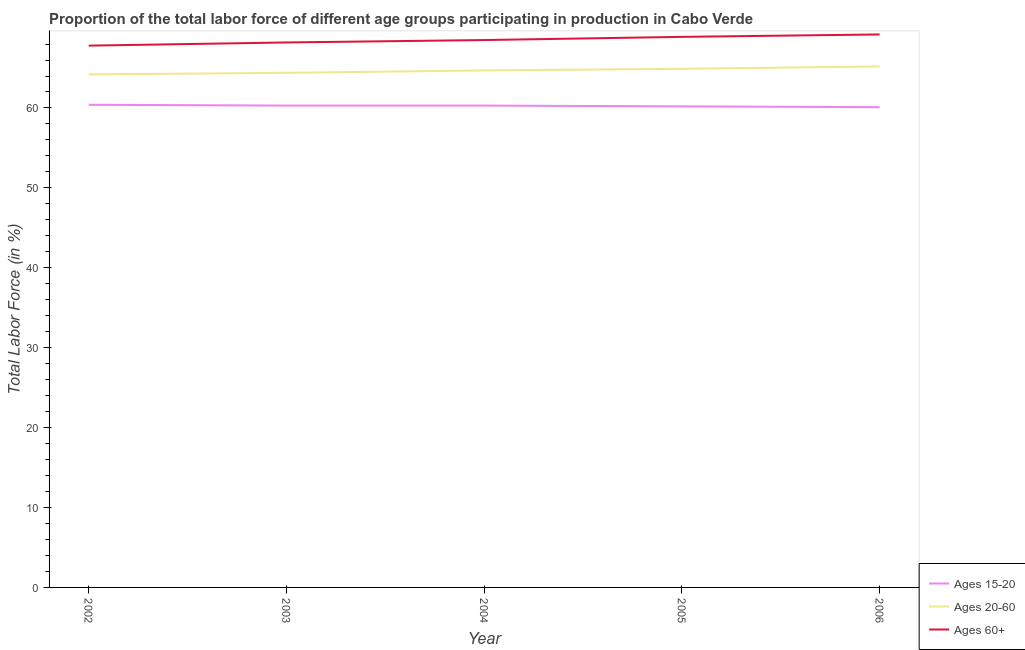What is the percentage of labor force within the age group 15-20 in 2002?
Give a very brief answer. 60.4. Across all years, what is the maximum percentage of labor force above age 60?
Provide a succinct answer. 69.2. Across all years, what is the minimum percentage of labor force within the age group 20-60?
Ensure brevity in your answer.  64.2. In which year was the percentage of labor force above age 60 maximum?
Your answer should be very brief. 2006. In which year was the percentage of labor force within the age group 20-60 minimum?
Ensure brevity in your answer.  2002. What is the total percentage of labor force within the age group 15-20 in the graph?
Your answer should be very brief. 301.3. What is the difference between the percentage of labor force above age 60 in 2005 and that in 2006?
Offer a very short reply. -0.3. What is the difference between the percentage of labor force above age 60 in 2006 and the percentage of labor force within the age group 20-60 in 2003?
Provide a succinct answer. 4.8. What is the average percentage of labor force within the age group 20-60 per year?
Provide a short and direct response. 64.68. In the year 2005, what is the difference between the percentage of labor force within the age group 20-60 and percentage of labor force above age 60?
Your response must be concise. -4. What is the ratio of the percentage of labor force within the age group 15-20 in 2004 to that in 2005?
Your answer should be very brief. 1. What is the difference between the highest and the second highest percentage of labor force above age 60?
Your response must be concise. 0.3. Is the sum of the percentage of labor force within the age group 15-20 in 2003 and 2004 greater than the maximum percentage of labor force above age 60 across all years?
Your answer should be compact. Yes. Is the percentage of labor force within the age group 15-20 strictly greater than the percentage of labor force within the age group 20-60 over the years?
Ensure brevity in your answer.  No. How many lines are there?
Provide a short and direct response. 3. How many years are there in the graph?
Ensure brevity in your answer.  5. What is the difference between two consecutive major ticks on the Y-axis?
Give a very brief answer. 10. Are the values on the major ticks of Y-axis written in scientific E-notation?
Provide a short and direct response. No. How many legend labels are there?
Keep it short and to the point. 3. What is the title of the graph?
Offer a terse response. Proportion of the total labor force of different age groups participating in production in Cabo Verde. What is the label or title of the Y-axis?
Offer a very short reply. Total Labor Force (in %). What is the Total Labor Force (in %) in Ages 15-20 in 2002?
Your answer should be very brief. 60.4. What is the Total Labor Force (in %) in Ages 20-60 in 2002?
Your answer should be very brief. 64.2. What is the Total Labor Force (in %) of Ages 60+ in 2002?
Provide a succinct answer. 67.8. What is the Total Labor Force (in %) of Ages 15-20 in 2003?
Your answer should be very brief. 60.3. What is the Total Labor Force (in %) of Ages 20-60 in 2003?
Offer a very short reply. 64.4. What is the Total Labor Force (in %) of Ages 60+ in 2003?
Offer a very short reply. 68.2. What is the Total Labor Force (in %) of Ages 15-20 in 2004?
Offer a terse response. 60.3. What is the Total Labor Force (in %) of Ages 20-60 in 2004?
Your answer should be compact. 64.7. What is the Total Labor Force (in %) in Ages 60+ in 2004?
Provide a succinct answer. 68.5. What is the Total Labor Force (in %) in Ages 15-20 in 2005?
Make the answer very short. 60.2. What is the Total Labor Force (in %) in Ages 20-60 in 2005?
Keep it short and to the point. 64.9. What is the Total Labor Force (in %) in Ages 60+ in 2005?
Offer a terse response. 68.9. What is the Total Labor Force (in %) of Ages 15-20 in 2006?
Provide a short and direct response. 60.1. What is the Total Labor Force (in %) of Ages 20-60 in 2006?
Offer a very short reply. 65.2. What is the Total Labor Force (in %) of Ages 60+ in 2006?
Offer a very short reply. 69.2. Across all years, what is the maximum Total Labor Force (in %) in Ages 15-20?
Your answer should be very brief. 60.4. Across all years, what is the maximum Total Labor Force (in %) in Ages 20-60?
Provide a succinct answer. 65.2. Across all years, what is the maximum Total Labor Force (in %) of Ages 60+?
Give a very brief answer. 69.2. Across all years, what is the minimum Total Labor Force (in %) in Ages 15-20?
Offer a very short reply. 60.1. Across all years, what is the minimum Total Labor Force (in %) of Ages 20-60?
Provide a short and direct response. 64.2. Across all years, what is the minimum Total Labor Force (in %) of Ages 60+?
Provide a succinct answer. 67.8. What is the total Total Labor Force (in %) in Ages 15-20 in the graph?
Provide a short and direct response. 301.3. What is the total Total Labor Force (in %) in Ages 20-60 in the graph?
Provide a short and direct response. 323.4. What is the total Total Labor Force (in %) of Ages 60+ in the graph?
Your answer should be compact. 342.6. What is the difference between the Total Labor Force (in %) of Ages 15-20 in 2002 and that in 2003?
Your answer should be very brief. 0.1. What is the difference between the Total Labor Force (in %) in Ages 15-20 in 2002 and that in 2004?
Offer a terse response. 0.1. What is the difference between the Total Labor Force (in %) of Ages 20-60 in 2002 and that in 2004?
Keep it short and to the point. -0.5. What is the difference between the Total Labor Force (in %) of Ages 60+ in 2002 and that in 2004?
Provide a short and direct response. -0.7. What is the difference between the Total Labor Force (in %) in Ages 15-20 in 2002 and that in 2005?
Offer a very short reply. 0.2. What is the difference between the Total Labor Force (in %) of Ages 20-60 in 2002 and that in 2005?
Keep it short and to the point. -0.7. What is the difference between the Total Labor Force (in %) in Ages 20-60 in 2002 and that in 2006?
Offer a terse response. -1. What is the difference between the Total Labor Force (in %) in Ages 60+ in 2002 and that in 2006?
Your response must be concise. -1.4. What is the difference between the Total Labor Force (in %) of Ages 15-20 in 2003 and that in 2004?
Your answer should be very brief. 0. What is the difference between the Total Labor Force (in %) of Ages 15-20 in 2003 and that in 2005?
Your answer should be very brief. 0.1. What is the difference between the Total Labor Force (in %) of Ages 20-60 in 2003 and that in 2005?
Provide a succinct answer. -0.5. What is the difference between the Total Labor Force (in %) of Ages 60+ in 2003 and that in 2005?
Your answer should be very brief. -0.7. What is the difference between the Total Labor Force (in %) in Ages 20-60 in 2003 and that in 2006?
Your answer should be compact. -0.8. What is the difference between the Total Labor Force (in %) of Ages 15-20 in 2004 and that in 2005?
Your answer should be very brief. 0.1. What is the difference between the Total Labor Force (in %) in Ages 15-20 in 2004 and that in 2006?
Give a very brief answer. 0.2. What is the difference between the Total Labor Force (in %) in Ages 20-60 in 2004 and that in 2006?
Make the answer very short. -0.5. What is the difference between the Total Labor Force (in %) of Ages 60+ in 2004 and that in 2006?
Your answer should be compact. -0.7. What is the difference between the Total Labor Force (in %) in Ages 15-20 in 2005 and that in 2006?
Ensure brevity in your answer.  0.1. What is the difference between the Total Labor Force (in %) of Ages 60+ in 2005 and that in 2006?
Your answer should be compact. -0.3. What is the difference between the Total Labor Force (in %) of Ages 15-20 in 2002 and the Total Labor Force (in %) of Ages 20-60 in 2003?
Give a very brief answer. -4. What is the difference between the Total Labor Force (in %) of Ages 20-60 in 2002 and the Total Labor Force (in %) of Ages 60+ in 2003?
Ensure brevity in your answer.  -4. What is the difference between the Total Labor Force (in %) of Ages 15-20 in 2002 and the Total Labor Force (in %) of Ages 60+ in 2004?
Give a very brief answer. -8.1. What is the difference between the Total Labor Force (in %) of Ages 20-60 in 2002 and the Total Labor Force (in %) of Ages 60+ in 2004?
Provide a succinct answer. -4.3. What is the difference between the Total Labor Force (in %) of Ages 15-20 in 2002 and the Total Labor Force (in %) of Ages 20-60 in 2005?
Make the answer very short. -4.5. What is the difference between the Total Labor Force (in %) in Ages 15-20 in 2002 and the Total Labor Force (in %) in Ages 20-60 in 2006?
Offer a terse response. -4.8. What is the difference between the Total Labor Force (in %) in Ages 15-20 in 2002 and the Total Labor Force (in %) in Ages 60+ in 2006?
Make the answer very short. -8.8. What is the difference between the Total Labor Force (in %) of Ages 15-20 in 2003 and the Total Labor Force (in %) of Ages 60+ in 2004?
Make the answer very short. -8.2. What is the difference between the Total Labor Force (in %) in Ages 20-60 in 2003 and the Total Labor Force (in %) in Ages 60+ in 2004?
Keep it short and to the point. -4.1. What is the difference between the Total Labor Force (in %) in Ages 15-20 in 2003 and the Total Labor Force (in %) in Ages 20-60 in 2005?
Give a very brief answer. -4.6. What is the difference between the Total Labor Force (in %) in Ages 15-20 in 2003 and the Total Labor Force (in %) in Ages 60+ in 2005?
Provide a succinct answer. -8.6. What is the difference between the Total Labor Force (in %) of Ages 20-60 in 2003 and the Total Labor Force (in %) of Ages 60+ in 2005?
Give a very brief answer. -4.5. What is the difference between the Total Labor Force (in %) of Ages 20-60 in 2004 and the Total Labor Force (in %) of Ages 60+ in 2005?
Offer a terse response. -4.2. What is the difference between the Total Labor Force (in %) of Ages 15-20 in 2004 and the Total Labor Force (in %) of Ages 20-60 in 2006?
Your response must be concise. -4.9. What is the difference between the Total Labor Force (in %) of Ages 20-60 in 2004 and the Total Labor Force (in %) of Ages 60+ in 2006?
Make the answer very short. -4.5. What is the difference between the Total Labor Force (in %) of Ages 15-20 in 2005 and the Total Labor Force (in %) of Ages 20-60 in 2006?
Offer a terse response. -5. What is the average Total Labor Force (in %) in Ages 15-20 per year?
Your answer should be very brief. 60.26. What is the average Total Labor Force (in %) in Ages 20-60 per year?
Ensure brevity in your answer.  64.68. What is the average Total Labor Force (in %) of Ages 60+ per year?
Make the answer very short. 68.52. In the year 2002, what is the difference between the Total Labor Force (in %) in Ages 20-60 and Total Labor Force (in %) in Ages 60+?
Ensure brevity in your answer.  -3.6. In the year 2003, what is the difference between the Total Labor Force (in %) of Ages 15-20 and Total Labor Force (in %) of Ages 60+?
Offer a very short reply. -7.9. In the year 2004, what is the difference between the Total Labor Force (in %) of Ages 15-20 and Total Labor Force (in %) of Ages 60+?
Your answer should be compact. -8.2. In the year 2005, what is the difference between the Total Labor Force (in %) in Ages 15-20 and Total Labor Force (in %) in Ages 20-60?
Give a very brief answer. -4.7. In the year 2006, what is the difference between the Total Labor Force (in %) in Ages 15-20 and Total Labor Force (in %) in Ages 60+?
Keep it short and to the point. -9.1. What is the ratio of the Total Labor Force (in %) in Ages 20-60 in 2002 to that in 2004?
Provide a short and direct response. 0.99. What is the ratio of the Total Labor Force (in %) of Ages 60+ in 2002 to that in 2004?
Your answer should be compact. 0.99. What is the ratio of the Total Labor Force (in %) of Ages 15-20 in 2002 to that in 2005?
Your response must be concise. 1. What is the ratio of the Total Labor Force (in %) in Ages 20-60 in 2002 to that in 2005?
Keep it short and to the point. 0.99. What is the ratio of the Total Labor Force (in %) of Ages 60+ in 2002 to that in 2005?
Keep it short and to the point. 0.98. What is the ratio of the Total Labor Force (in %) of Ages 20-60 in 2002 to that in 2006?
Your response must be concise. 0.98. What is the ratio of the Total Labor Force (in %) of Ages 60+ in 2002 to that in 2006?
Ensure brevity in your answer.  0.98. What is the ratio of the Total Labor Force (in %) of Ages 60+ in 2003 to that in 2004?
Offer a terse response. 1. What is the ratio of the Total Labor Force (in %) in Ages 20-60 in 2003 to that in 2005?
Your answer should be compact. 0.99. What is the ratio of the Total Labor Force (in %) of Ages 60+ in 2003 to that in 2005?
Your answer should be very brief. 0.99. What is the ratio of the Total Labor Force (in %) in Ages 20-60 in 2003 to that in 2006?
Keep it short and to the point. 0.99. What is the ratio of the Total Labor Force (in %) in Ages 60+ in 2003 to that in 2006?
Provide a succinct answer. 0.99. What is the ratio of the Total Labor Force (in %) in Ages 20-60 in 2004 to that in 2006?
Provide a succinct answer. 0.99. What is the ratio of the Total Labor Force (in %) in Ages 60+ in 2004 to that in 2006?
Your response must be concise. 0.99. What is the ratio of the Total Labor Force (in %) of Ages 15-20 in 2005 to that in 2006?
Offer a very short reply. 1. What is the ratio of the Total Labor Force (in %) in Ages 20-60 in 2005 to that in 2006?
Give a very brief answer. 1. What is the ratio of the Total Labor Force (in %) of Ages 60+ in 2005 to that in 2006?
Offer a terse response. 1. What is the difference between the highest and the second highest Total Labor Force (in %) of Ages 15-20?
Provide a short and direct response. 0.1. What is the difference between the highest and the second highest Total Labor Force (in %) of Ages 20-60?
Ensure brevity in your answer.  0.3. What is the difference between the highest and the second highest Total Labor Force (in %) of Ages 60+?
Ensure brevity in your answer.  0.3. What is the difference between the highest and the lowest Total Labor Force (in %) of Ages 15-20?
Make the answer very short. 0.3. What is the difference between the highest and the lowest Total Labor Force (in %) in Ages 60+?
Your response must be concise. 1.4. 